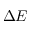Convert formula to latex. <formula><loc_0><loc_0><loc_500><loc_500>\Delta E</formula> 